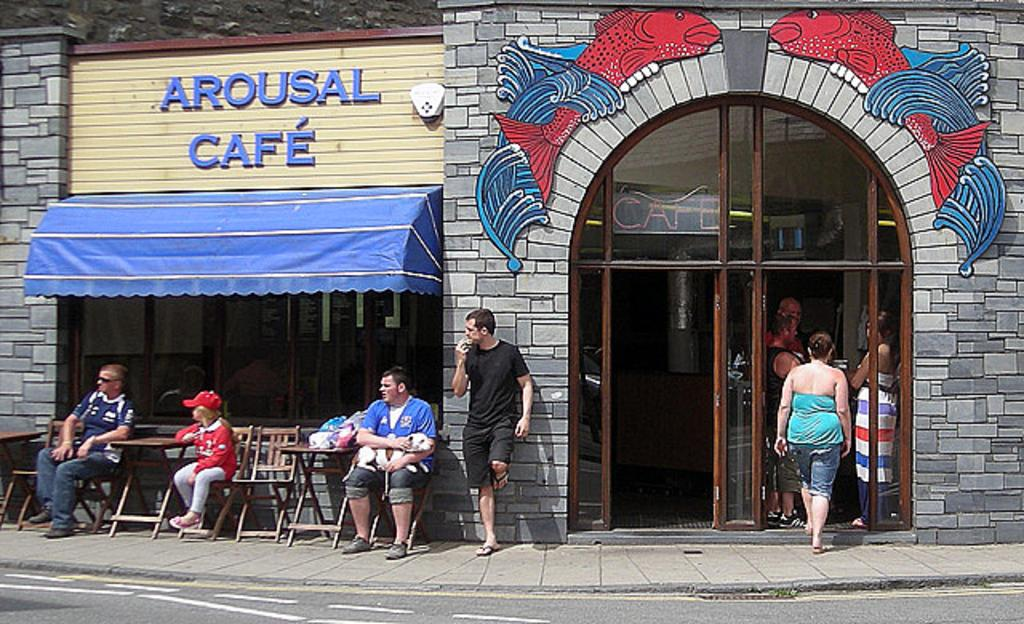What type of establishment is in the center of the image? There is a cafe in the center of the image. Can you describe the entrance to the cafe? There is a door in the image. What are the people in the image doing? There are people sitting on chairs in the image. What can be seen at the bottom of the image? There is a road visible at the bottom of the image. What sense is being stimulated by the lunchroom in the image? There is no lunchroom present in the image, and therefore no sense is being stimulated by it. 